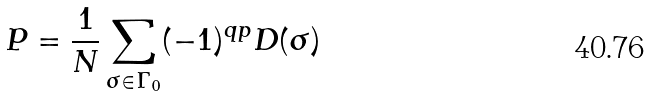Convert formula to latex. <formula><loc_0><loc_0><loc_500><loc_500>P = \frac { 1 } { N } \sum _ { \sigma \in \Gamma _ { 0 } } ( - 1 ) ^ { q p } D ( \sigma )</formula> 